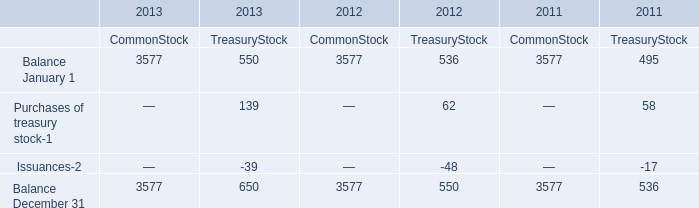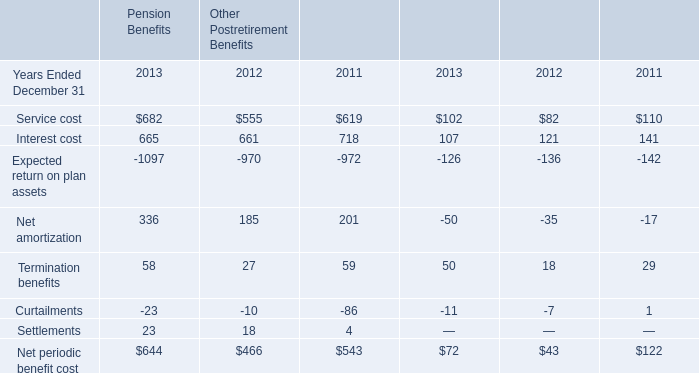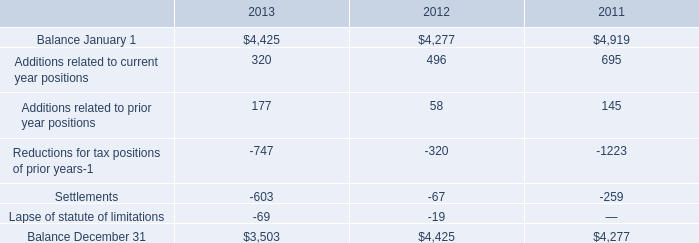what was the ratio of interest and penalties associated with uncertain tax positions in 2013 to 2012 
Computations: (319 / 88)
Answer: 3.625. 